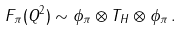<formula> <loc_0><loc_0><loc_500><loc_500>F _ { \pi } ( Q ^ { 2 } ) \sim \phi _ { \pi } \otimes T _ { H } \otimes \phi _ { \pi } \, .</formula> 